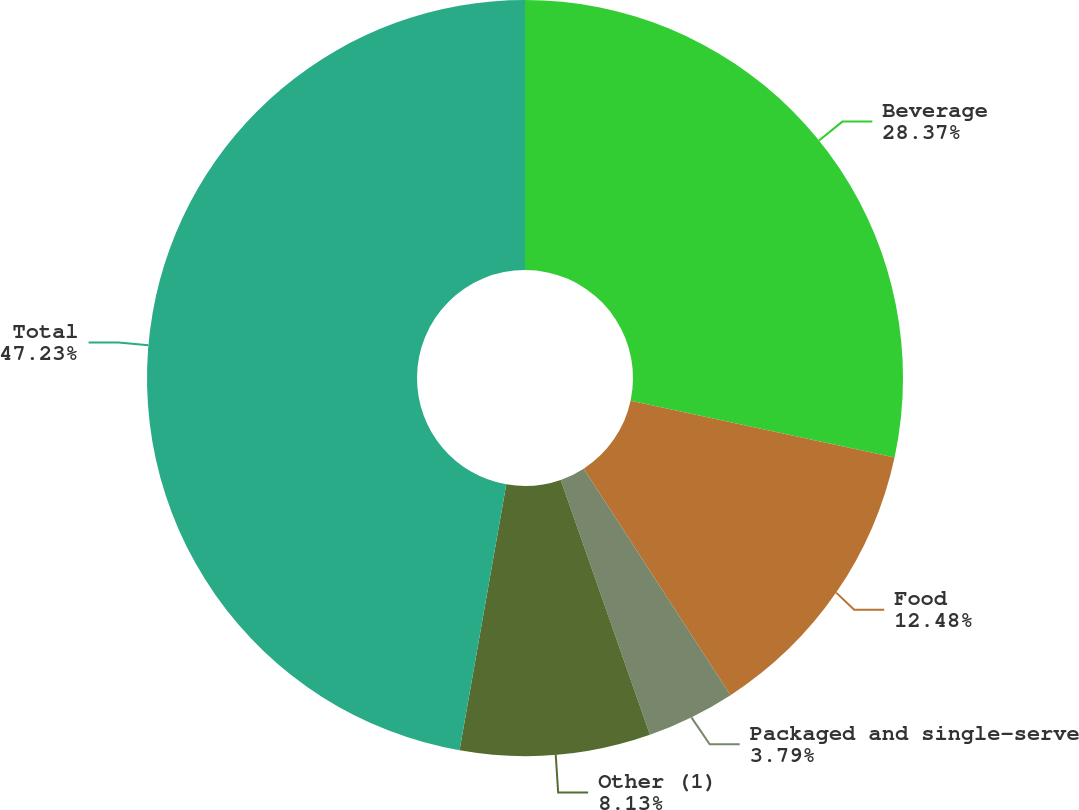Convert chart to OTSL. <chart><loc_0><loc_0><loc_500><loc_500><pie_chart><fcel>Beverage<fcel>Food<fcel>Packaged and single-serve<fcel>Other (1)<fcel>Total<nl><fcel>28.37%<fcel>12.48%<fcel>3.79%<fcel>8.13%<fcel>47.23%<nl></chart> 